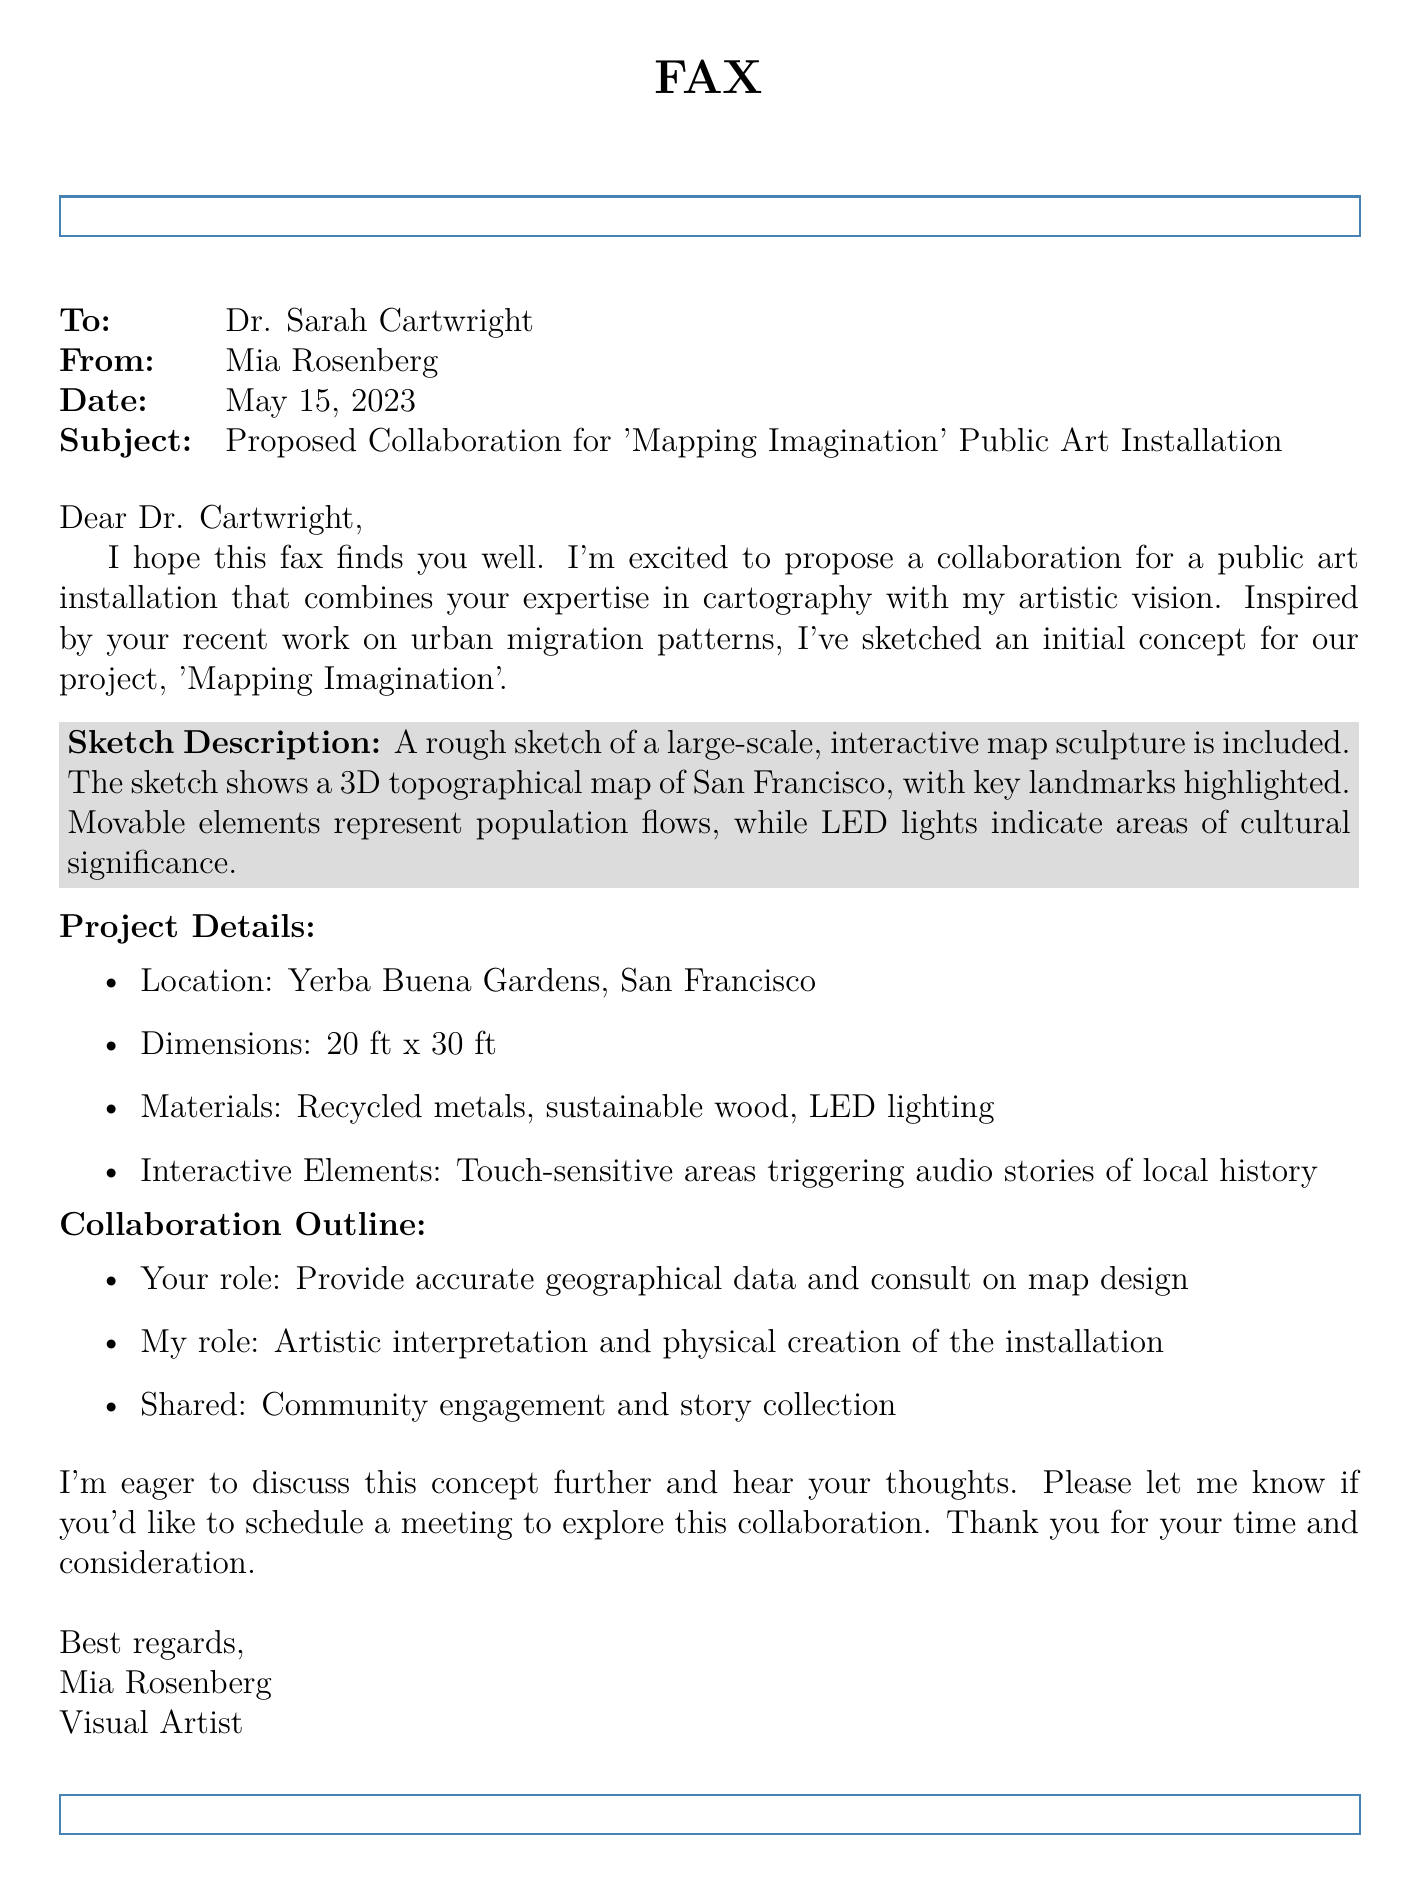What is the name of the proposed art installation? The title of the art installation is mentioned in the subject line of the document.
Answer: Mapping Imagination Who is the recipient of the fax? The document clearly states to whom the fax is addressed in the "To" field.
Answer: Dr. Sarah Cartwright What date was the fax sent? The date can be found in the "Date" field of the document.
Answer: May 15, 2023 What location is mentioned for the installation? The location is specified in the project details section.
Answer: Yerba Buena Gardens, San Francisco What materials are listed for the installation? A list of materials used for the installation is provided in the project details.
Answer: Recycled metals, sustainable wood, LED lighting What is Mia Rosenberg's role in the collaboration? The document outlines the roles of each collaborator, particularly Mia's.
Answer: Artistic interpretation and physical creation of the installation What interactive element is included in the installation? The project details specify the nature of the interactive elements.
Answer: Touch-sensitive areas triggering audio stories of local history What was the format of communication in this document? The document can be categorized based on its structure and purpose.
Answer: Fax What aspect of urban geography inspired the art project? The document references a specific area of Dr. Cartwright's work that influenced Mia's concept.
Answer: Urban migration patterns 